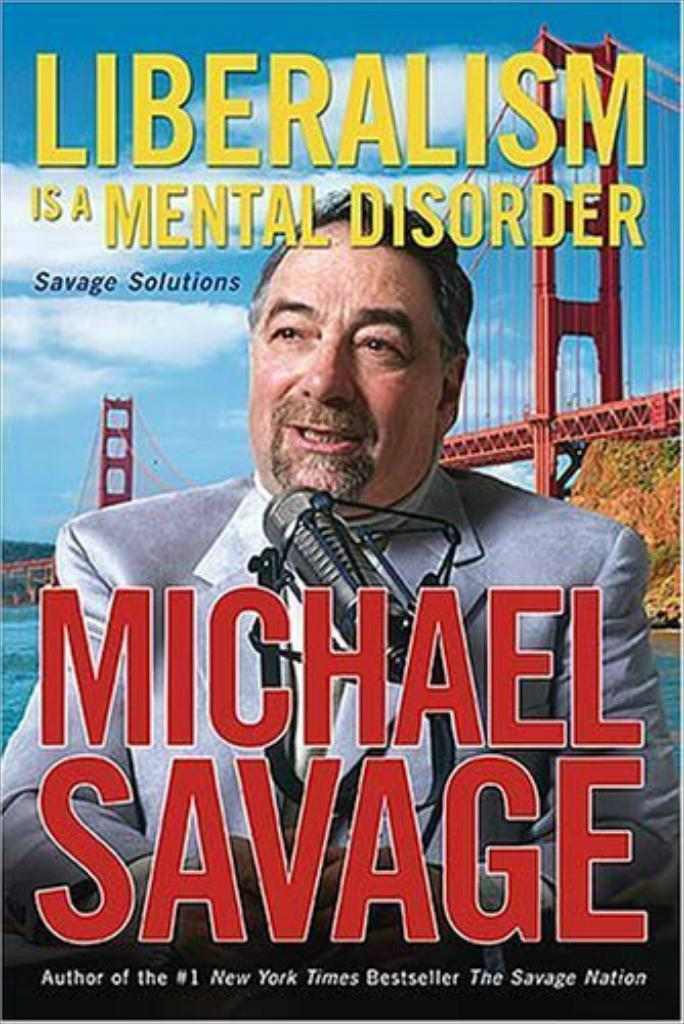What is the main subject of the poster in the image? The poster contains an image of a person, a mic, and a bridge. What can be seen in addition to the images on the poster? There is writing on the poster. What is the condition of the sky in the image? The sky in the image is cloudy. How much debt does the person on the poster owe to the pig in the image? There is no pig present in the image, and therefore no such debt can be observed. 